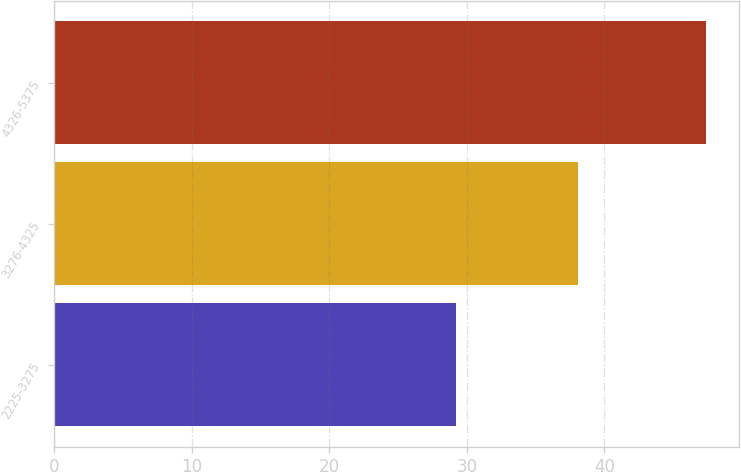Convert chart. <chart><loc_0><loc_0><loc_500><loc_500><bar_chart><fcel>2225-3275<fcel>3276-4325<fcel>4326-5375<nl><fcel>29.25<fcel>38.05<fcel>47.4<nl></chart> 